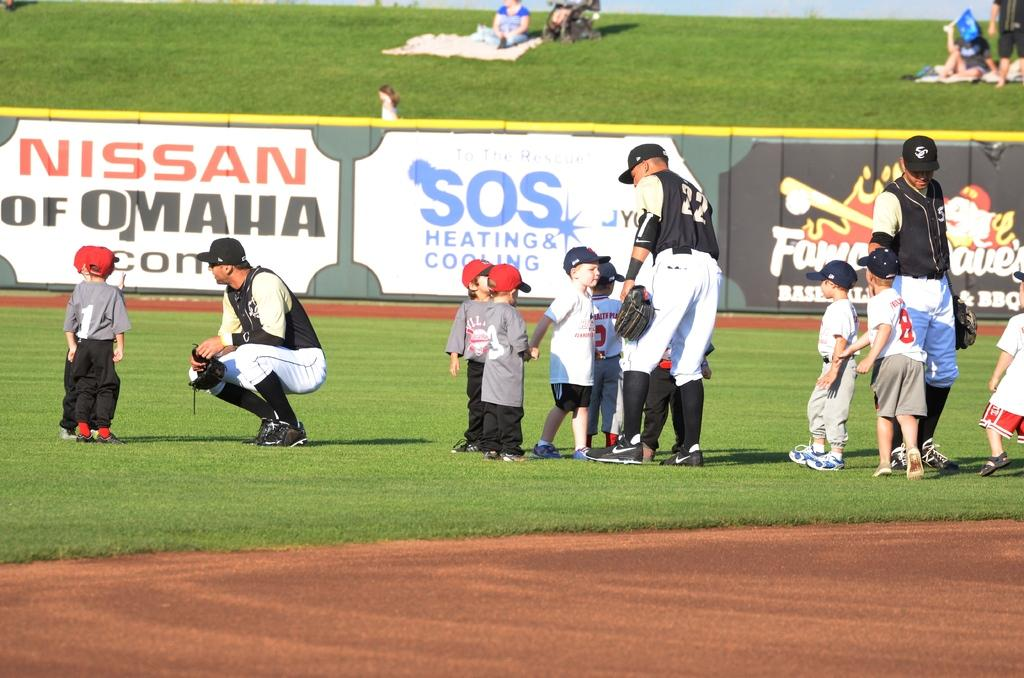<image>
Give a short and clear explanation of the subsequent image. Young children stand on the field with baseball players in front of an ad for SOS Heating and Cooling 